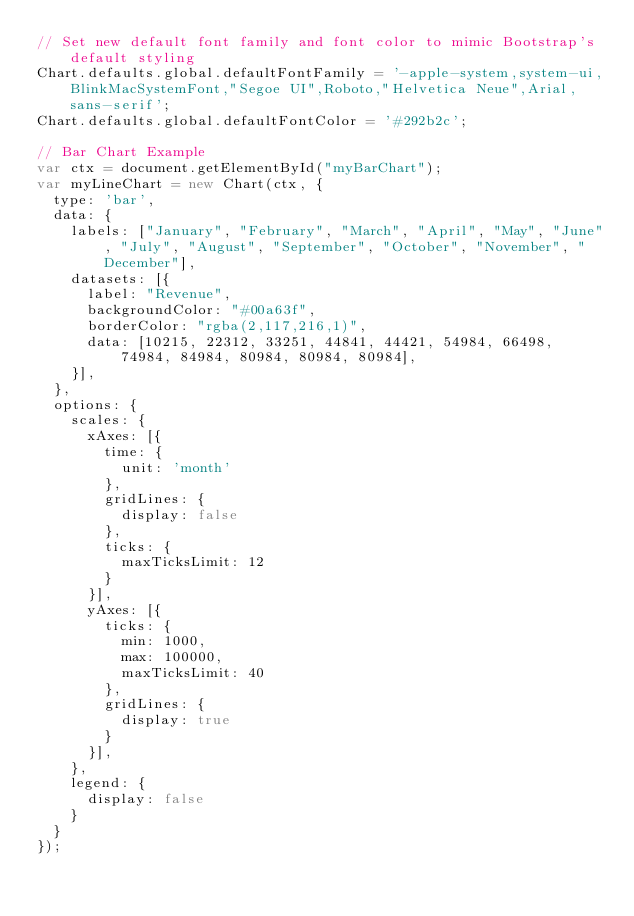<code> <loc_0><loc_0><loc_500><loc_500><_JavaScript_>// Set new default font family and font color to mimic Bootstrap's default styling
Chart.defaults.global.defaultFontFamily = '-apple-system,system-ui,BlinkMacSystemFont,"Segoe UI",Roboto,"Helvetica Neue",Arial,sans-serif';
Chart.defaults.global.defaultFontColor = '#292b2c';

// Bar Chart Example
var ctx = document.getElementById("myBarChart");
var myLineChart = new Chart(ctx, {
  type: 'bar',
  data: {
    labels: ["January", "February", "March", "April", "May", "June", "July", "August", "September", "October", "November", "December"],
    datasets: [{
      label: "Revenue",
      backgroundColor: "#00a63f",
      borderColor: "rgba(2,117,216,1)",
      data: [10215, 22312, 33251, 44841, 44421, 54984, 66498, 74984, 84984, 80984, 80984, 80984],
    }],
  },
  options: {
    scales: {
      xAxes: [{
        time: {
          unit: 'month'
        },
        gridLines: {
          display: false
        },
        ticks: {
          maxTicksLimit: 12
        }
      }],
      yAxes: [{
        ticks: {
          min: 1000,
          max: 100000,
          maxTicksLimit: 40
        },
        gridLines: {
          display: true
        }
      }],
    },
    legend: {
      display: false
    }
  }
});
</code> 